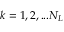<formula> <loc_0><loc_0><loc_500><loc_500>k = 1 , 2 , \dots N _ { L }</formula> 